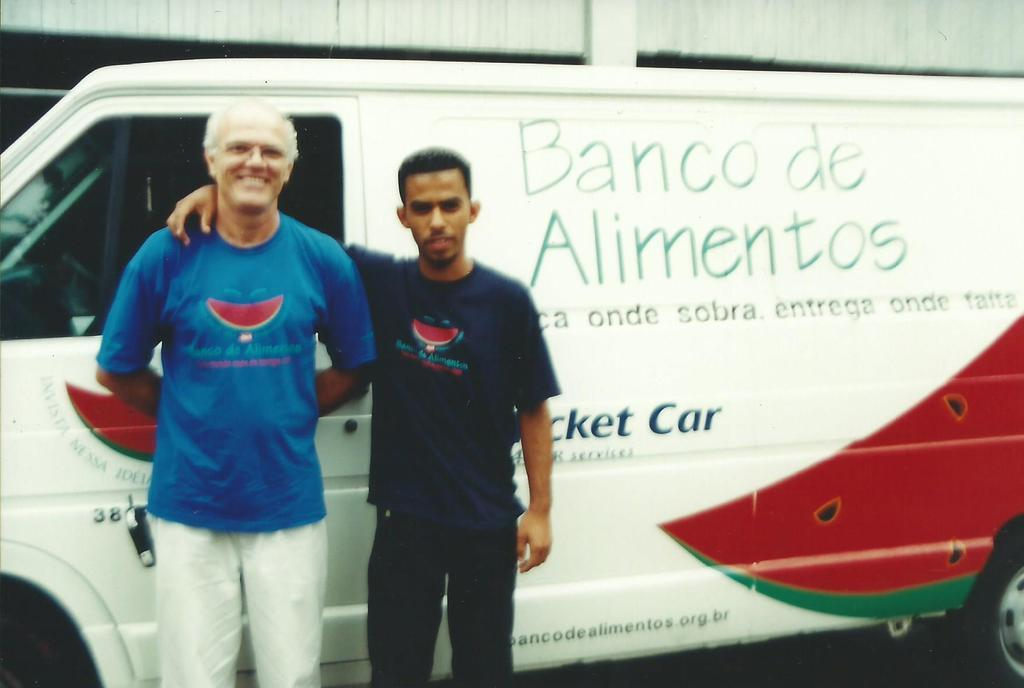Who or what can be seen in the image? There are people in the image. What else is present in the image besides the people? There is a vehicle and a wall in the image. Can you describe the vehicle in the image? The vehicle has something written on it. How many tomatoes are on the list in the image? There is no list or tomatoes present in the image. 